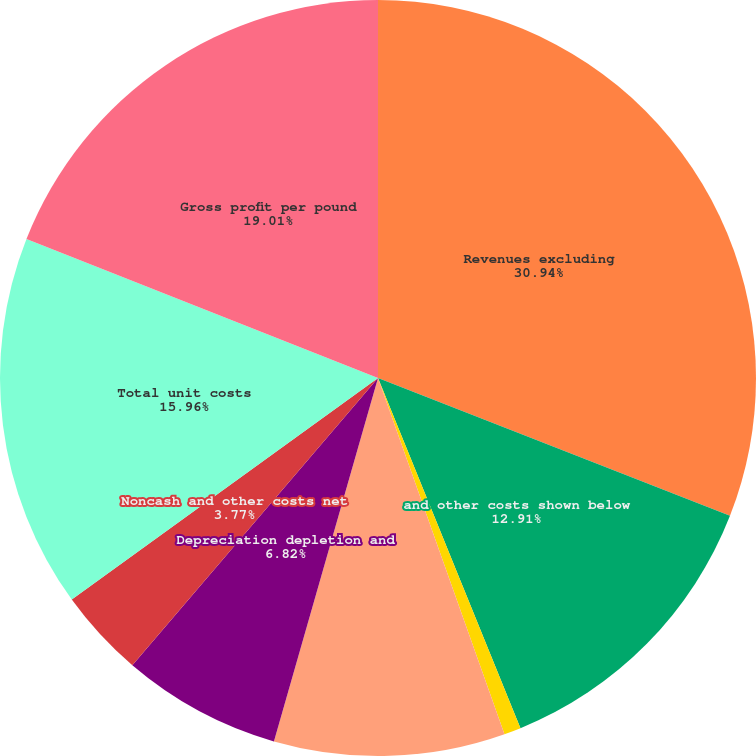<chart> <loc_0><loc_0><loc_500><loc_500><pie_chart><fcel>Revenues excluding<fcel>and other costs shown below<fcel>Royalty on metals<fcel>Unit net cash costs<fcel>Depreciation depletion and<fcel>Noncash and other costs net<fcel>Total unit costs<fcel>Gross profit per pound<nl><fcel>30.94%<fcel>12.91%<fcel>0.72%<fcel>9.87%<fcel>6.82%<fcel>3.77%<fcel>15.96%<fcel>19.01%<nl></chart> 